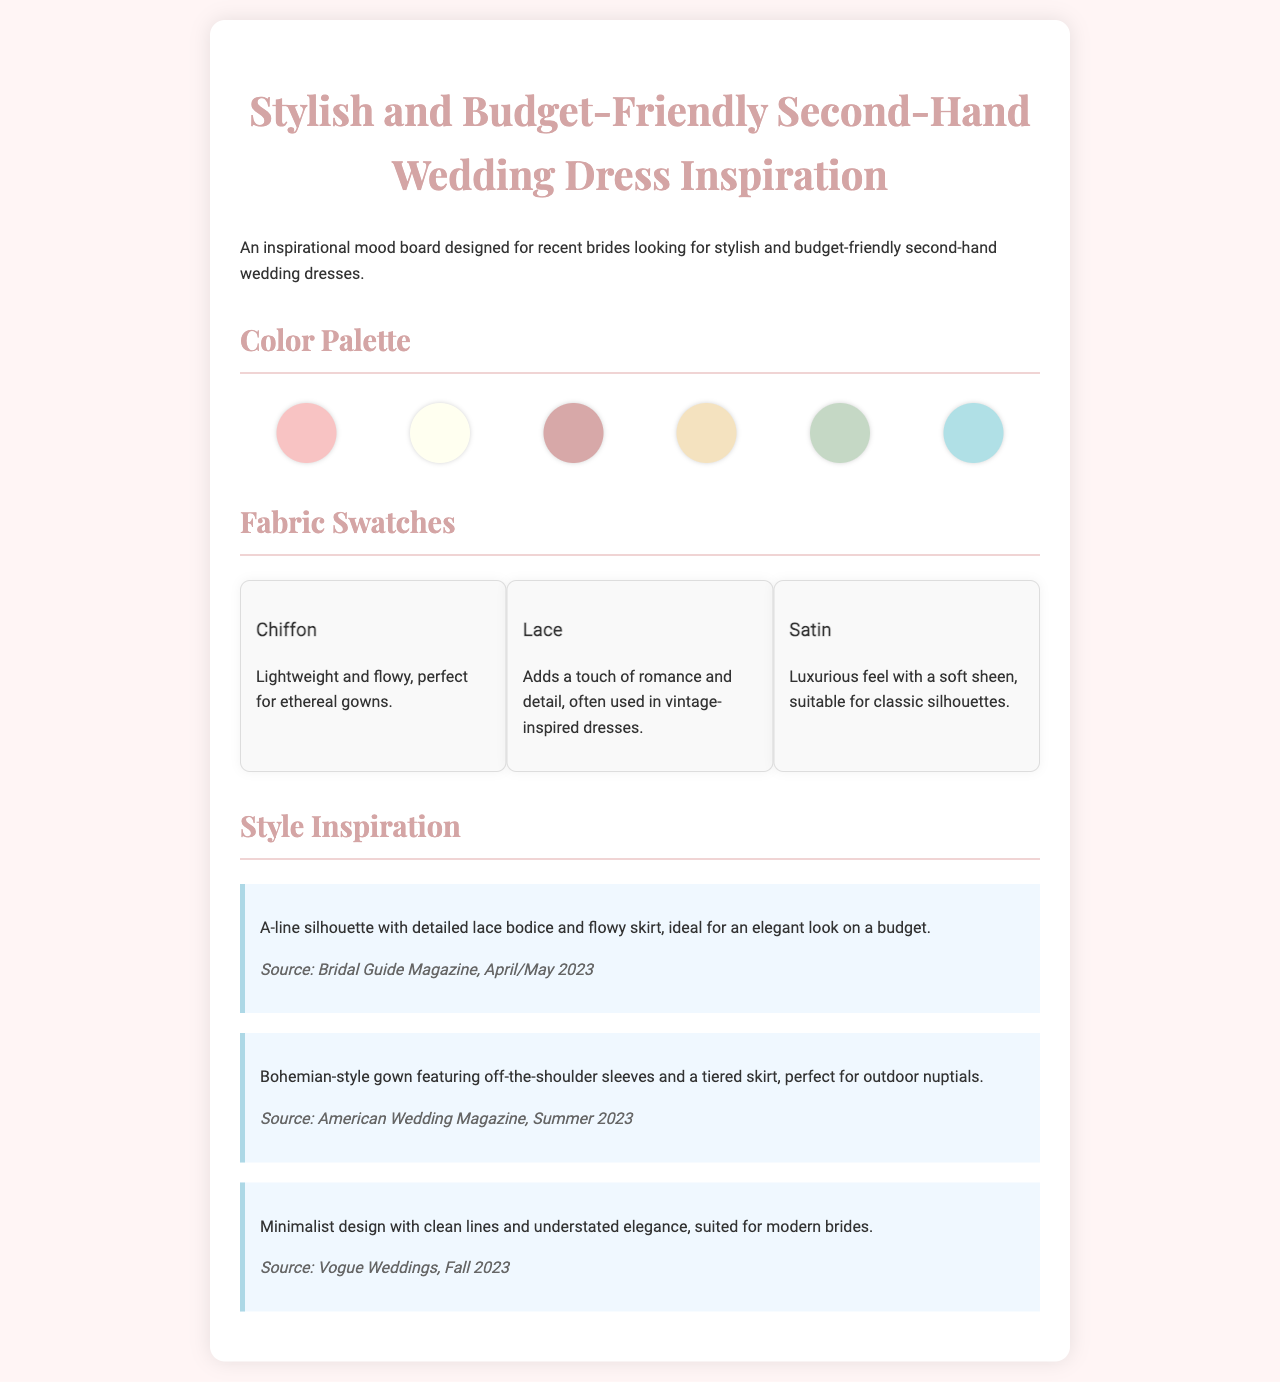what is the title of the mood board? The title is the main heading of the document, which provides the theme of the inspiration presented.
Answer: Stylish and Budget-Friendly Second-Hand Wedding Dress Inspiration how many color swatches are there? The number of color swatches can be counted from the color palette section in the document.
Answer: 6 name one fabric mentioned in the swatches. The fabric swatch section lists various fabrics along with their descriptions.
Answer: Chiffon what style of gown is suggested for outdoor nuptials? This is found in the style inspiration section, detailing a specific type of dress suitable for a certain setting.
Answer: Bohemian-style gown which magazine features the A-line silhouette design? The source of the style clipping provides the name of the magazine that featured the design.
Answer: Bridal Guide Magazine what color is associated with the swatch titled “Dusty Rose”? Answering this requires knowledge of the color representations in the palette section of the document.
Answer: #D7A8A8 name a fabric that adds romance and detail. The description for one of the fabric swatches specifically mentions this characteristic.
Answer: Lace which style is suitable for modern brides? The style inspiration section describes designs tailored for a contemporary audience.
Answer: Minimalist design 